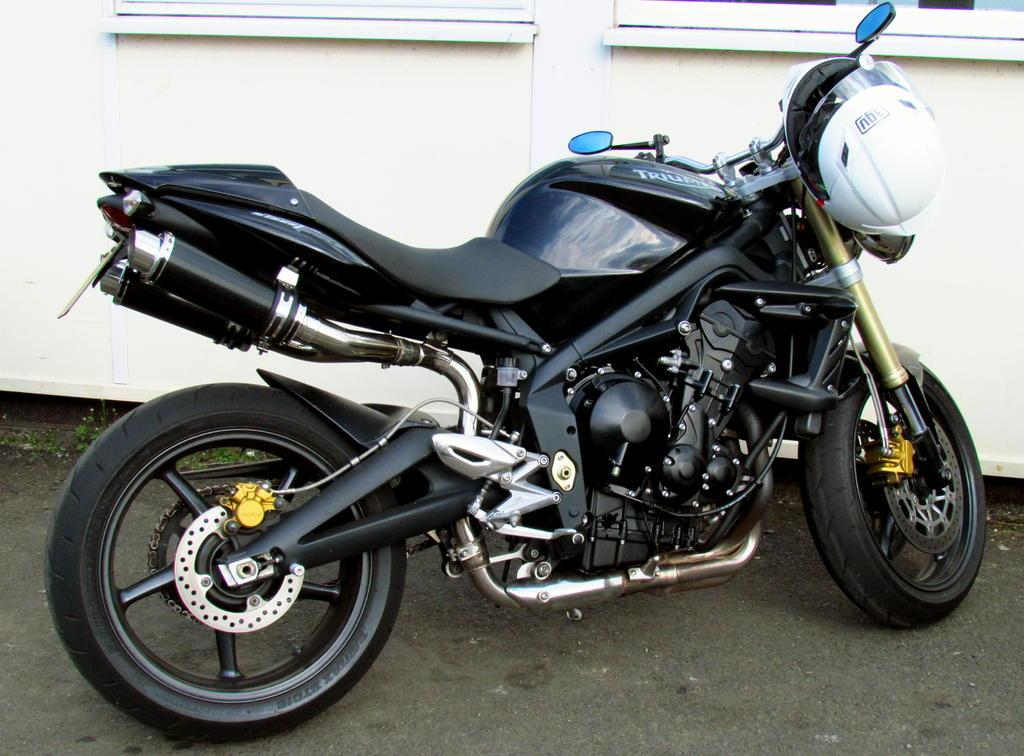What is the main subject in the center of the image? There is a bike in the center of the image. What safety accessory is attached to the bike? There is a helmet on the handle of the bike. What can be seen at the top side of the image? There appear to be windows at the top side of the image. Where is the queen sitting in the image? There is no queen present in the image. What type of plants can be seen growing near the bike? There is no mention of plants in the image. 